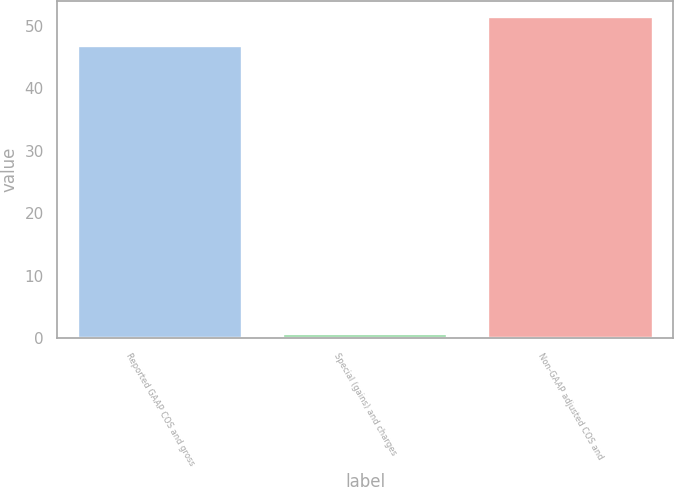<chart> <loc_0><loc_0><loc_500><loc_500><bar_chart><fcel>Reported GAAP COS and gross<fcel>Special (gains) and charges<fcel>Non-GAAP adjusted COS and<nl><fcel>46.7<fcel>0.6<fcel>51.37<nl></chart> 